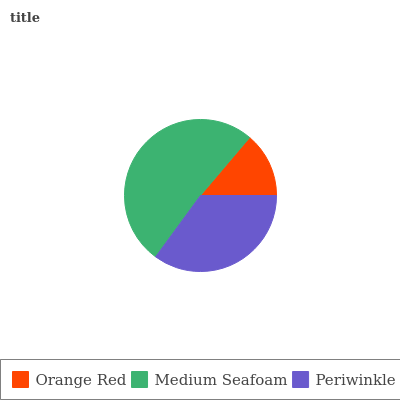Is Orange Red the minimum?
Answer yes or no. Yes. Is Medium Seafoam the maximum?
Answer yes or no. Yes. Is Periwinkle the minimum?
Answer yes or no. No. Is Periwinkle the maximum?
Answer yes or no. No. Is Medium Seafoam greater than Periwinkle?
Answer yes or no. Yes. Is Periwinkle less than Medium Seafoam?
Answer yes or no. Yes. Is Periwinkle greater than Medium Seafoam?
Answer yes or no. No. Is Medium Seafoam less than Periwinkle?
Answer yes or no. No. Is Periwinkle the high median?
Answer yes or no. Yes. Is Periwinkle the low median?
Answer yes or no. Yes. Is Orange Red the high median?
Answer yes or no. No. Is Medium Seafoam the low median?
Answer yes or no. No. 